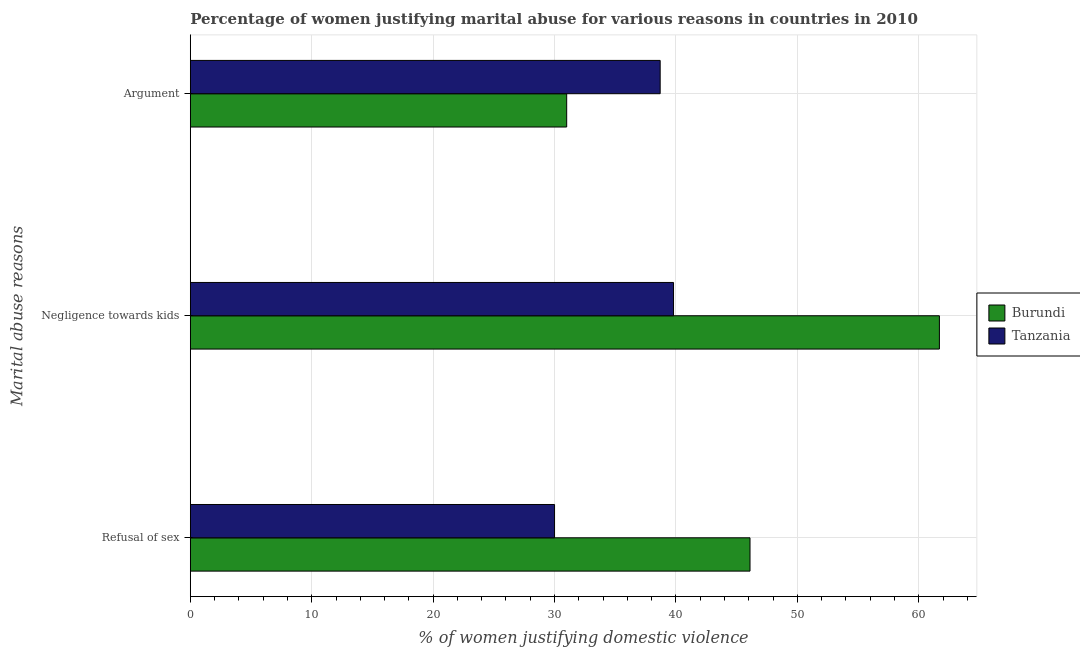Are the number of bars on each tick of the Y-axis equal?
Ensure brevity in your answer.  Yes. How many bars are there on the 1st tick from the top?
Offer a very short reply. 2. What is the label of the 1st group of bars from the top?
Offer a very short reply. Argument. What is the percentage of women justifying domestic violence due to negligence towards kids in Tanzania?
Your answer should be compact. 39.8. Across all countries, what is the maximum percentage of women justifying domestic violence due to arguments?
Your answer should be very brief. 38.7. Across all countries, what is the minimum percentage of women justifying domestic violence due to negligence towards kids?
Ensure brevity in your answer.  39.8. In which country was the percentage of women justifying domestic violence due to negligence towards kids maximum?
Offer a terse response. Burundi. In which country was the percentage of women justifying domestic violence due to arguments minimum?
Your answer should be very brief. Burundi. What is the total percentage of women justifying domestic violence due to refusal of sex in the graph?
Provide a short and direct response. 76.1. What is the difference between the percentage of women justifying domestic violence due to arguments in Burundi and that in Tanzania?
Your response must be concise. -7.7. What is the difference between the percentage of women justifying domestic violence due to arguments in Tanzania and the percentage of women justifying domestic violence due to refusal of sex in Burundi?
Make the answer very short. -7.4. What is the average percentage of women justifying domestic violence due to negligence towards kids per country?
Provide a short and direct response. 50.75. What is the difference between the percentage of women justifying domestic violence due to refusal of sex and percentage of women justifying domestic violence due to arguments in Tanzania?
Give a very brief answer. -8.7. In how many countries, is the percentage of women justifying domestic violence due to arguments greater than 12 %?
Your answer should be compact. 2. What is the ratio of the percentage of women justifying domestic violence due to refusal of sex in Burundi to that in Tanzania?
Give a very brief answer. 1.54. Is the percentage of women justifying domestic violence due to negligence towards kids in Burundi less than that in Tanzania?
Offer a very short reply. No. Is the difference between the percentage of women justifying domestic violence due to refusal of sex in Burundi and Tanzania greater than the difference between the percentage of women justifying domestic violence due to negligence towards kids in Burundi and Tanzania?
Provide a succinct answer. No. What is the difference between the highest and the second highest percentage of women justifying domestic violence due to arguments?
Make the answer very short. 7.7. What is the difference between the highest and the lowest percentage of women justifying domestic violence due to arguments?
Your response must be concise. 7.7. In how many countries, is the percentage of women justifying domestic violence due to refusal of sex greater than the average percentage of women justifying domestic violence due to refusal of sex taken over all countries?
Your answer should be compact. 1. What does the 1st bar from the top in Negligence towards kids represents?
Provide a succinct answer. Tanzania. What does the 2nd bar from the bottom in Negligence towards kids represents?
Give a very brief answer. Tanzania. Is it the case that in every country, the sum of the percentage of women justifying domestic violence due to refusal of sex and percentage of women justifying domestic violence due to negligence towards kids is greater than the percentage of women justifying domestic violence due to arguments?
Ensure brevity in your answer.  Yes. How many bars are there?
Keep it short and to the point. 6. Are all the bars in the graph horizontal?
Give a very brief answer. Yes. Are the values on the major ticks of X-axis written in scientific E-notation?
Make the answer very short. No. How many legend labels are there?
Your answer should be compact. 2. How are the legend labels stacked?
Make the answer very short. Vertical. What is the title of the graph?
Your answer should be very brief. Percentage of women justifying marital abuse for various reasons in countries in 2010. What is the label or title of the X-axis?
Offer a very short reply. % of women justifying domestic violence. What is the label or title of the Y-axis?
Give a very brief answer. Marital abuse reasons. What is the % of women justifying domestic violence of Burundi in Refusal of sex?
Give a very brief answer. 46.1. What is the % of women justifying domestic violence of Tanzania in Refusal of sex?
Make the answer very short. 30. What is the % of women justifying domestic violence of Burundi in Negligence towards kids?
Make the answer very short. 61.7. What is the % of women justifying domestic violence in Tanzania in Negligence towards kids?
Give a very brief answer. 39.8. What is the % of women justifying domestic violence in Burundi in Argument?
Keep it short and to the point. 31. What is the % of women justifying domestic violence in Tanzania in Argument?
Provide a succinct answer. 38.7. Across all Marital abuse reasons, what is the maximum % of women justifying domestic violence of Burundi?
Offer a very short reply. 61.7. Across all Marital abuse reasons, what is the maximum % of women justifying domestic violence of Tanzania?
Keep it short and to the point. 39.8. What is the total % of women justifying domestic violence in Burundi in the graph?
Provide a short and direct response. 138.8. What is the total % of women justifying domestic violence of Tanzania in the graph?
Offer a terse response. 108.5. What is the difference between the % of women justifying domestic violence of Burundi in Refusal of sex and that in Negligence towards kids?
Make the answer very short. -15.6. What is the difference between the % of women justifying domestic violence of Burundi in Negligence towards kids and that in Argument?
Offer a very short reply. 30.7. What is the difference between the % of women justifying domestic violence of Tanzania in Negligence towards kids and that in Argument?
Make the answer very short. 1.1. What is the difference between the % of women justifying domestic violence in Burundi in Refusal of sex and the % of women justifying domestic violence in Tanzania in Negligence towards kids?
Give a very brief answer. 6.3. What is the average % of women justifying domestic violence in Burundi per Marital abuse reasons?
Your answer should be very brief. 46.27. What is the average % of women justifying domestic violence in Tanzania per Marital abuse reasons?
Provide a succinct answer. 36.17. What is the difference between the % of women justifying domestic violence of Burundi and % of women justifying domestic violence of Tanzania in Negligence towards kids?
Your answer should be compact. 21.9. What is the ratio of the % of women justifying domestic violence of Burundi in Refusal of sex to that in Negligence towards kids?
Offer a very short reply. 0.75. What is the ratio of the % of women justifying domestic violence in Tanzania in Refusal of sex to that in Negligence towards kids?
Offer a very short reply. 0.75. What is the ratio of the % of women justifying domestic violence in Burundi in Refusal of sex to that in Argument?
Offer a very short reply. 1.49. What is the ratio of the % of women justifying domestic violence in Tanzania in Refusal of sex to that in Argument?
Give a very brief answer. 0.78. What is the ratio of the % of women justifying domestic violence of Burundi in Negligence towards kids to that in Argument?
Your answer should be very brief. 1.99. What is the ratio of the % of women justifying domestic violence of Tanzania in Negligence towards kids to that in Argument?
Offer a terse response. 1.03. What is the difference between the highest and the second highest % of women justifying domestic violence in Burundi?
Your answer should be very brief. 15.6. What is the difference between the highest and the second highest % of women justifying domestic violence in Tanzania?
Provide a succinct answer. 1.1. What is the difference between the highest and the lowest % of women justifying domestic violence in Burundi?
Provide a succinct answer. 30.7. 